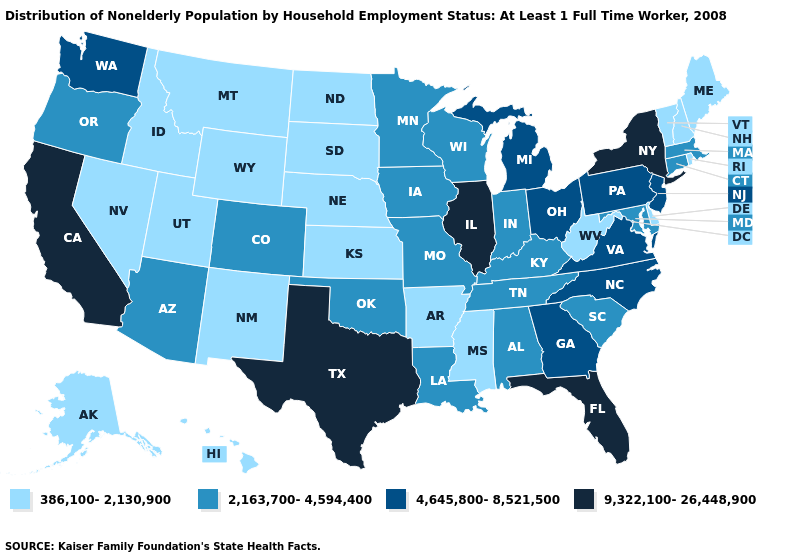Does Texas have the highest value in the USA?
Write a very short answer. Yes. Which states hav the highest value in the West?
Keep it brief. California. Does North Dakota have the lowest value in the MidWest?
Give a very brief answer. Yes. Name the states that have a value in the range 9,322,100-26,448,900?
Quick response, please. California, Florida, Illinois, New York, Texas. Does the map have missing data?
Give a very brief answer. No. What is the value of Indiana?
Write a very short answer. 2,163,700-4,594,400. Which states hav the highest value in the Northeast?
Concise answer only. New York. What is the value of Virginia?
Give a very brief answer. 4,645,800-8,521,500. Does Ohio have the highest value in the USA?
Give a very brief answer. No. What is the value of Arkansas?
Short answer required. 386,100-2,130,900. Among the states that border Indiana , does Illinois have the lowest value?
Keep it brief. No. What is the lowest value in the USA?
Answer briefly. 386,100-2,130,900. Among the states that border New Jersey , which have the highest value?
Keep it brief. New York. Name the states that have a value in the range 9,322,100-26,448,900?
Write a very short answer. California, Florida, Illinois, New York, Texas. Which states have the lowest value in the USA?
Answer briefly. Alaska, Arkansas, Delaware, Hawaii, Idaho, Kansas, Maine, Mississippi, Montana, Nebraska, Nevada, New Hampshire, New Mexico, North Dakota, Rhode Island, South Dakota, Utah, Vermont, West Virginia, Wyoming. 